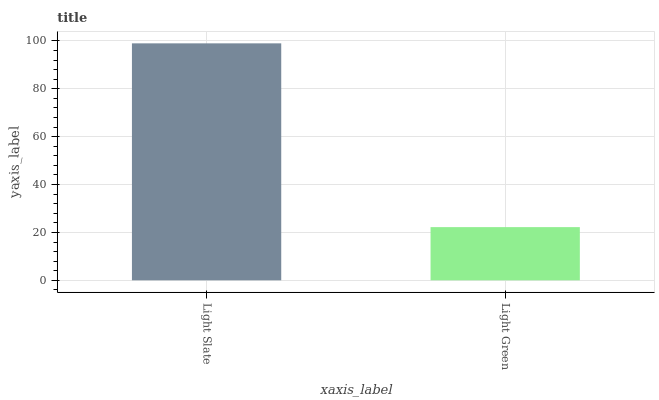Is Light Green the minimum?
Answer yes or no. Yes. Is Light Slate the maximum?
Answer yes or no. Yes. Is Light Green the maximum?
Answer yes or no. No. Is Light Slate greater than Light Green?
Answer yes or no. Yes. Is Light Green less than Light Slate?
Answer yes or no. Yes. Is Light Green greater than Light Slate?
Answer yes or no. No. Is Light Slate less than Light Green?
Answer yes or no. No. Is Light Slate the high median?
Answer yes or no. Yes. Is Light Green the low median?
Answer yes or no. Yes. Is Light Green the high median?
Answer yes or no. No. Is Light Slate the low median?
Answer yes or no. No. 